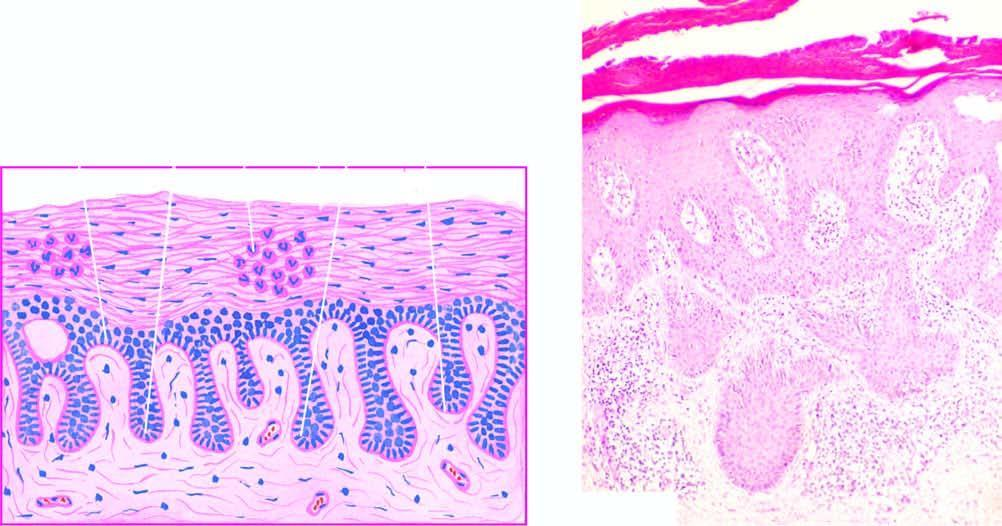whose lower portion is there?
Answer the question using a single word or phrase. Rete ridges 